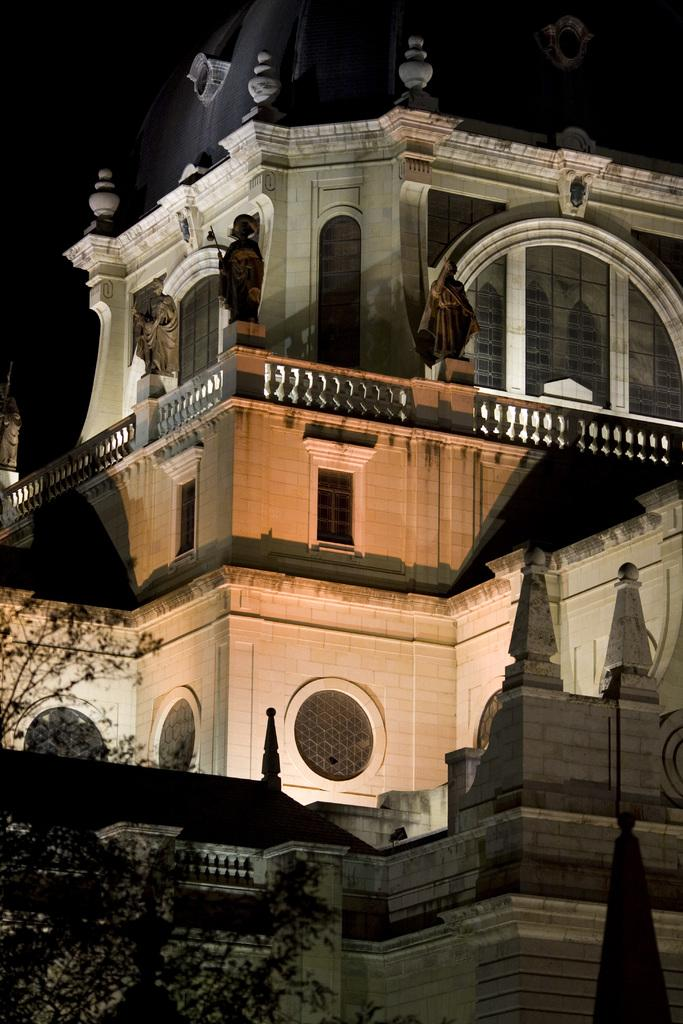What is the main structure in the image? There is a big fort in the image. What color is the fort? The fort is in white color. Are there any additional features on the fort? Yes, there are statues on the fort. What can be seen on the left side of the image? There is a tree on the left side of the image. How does the feeling of the fort change throughout the day in the image? The image does not convey any feelings or emotions, and there is no indication of the fort changing throughout the day. 